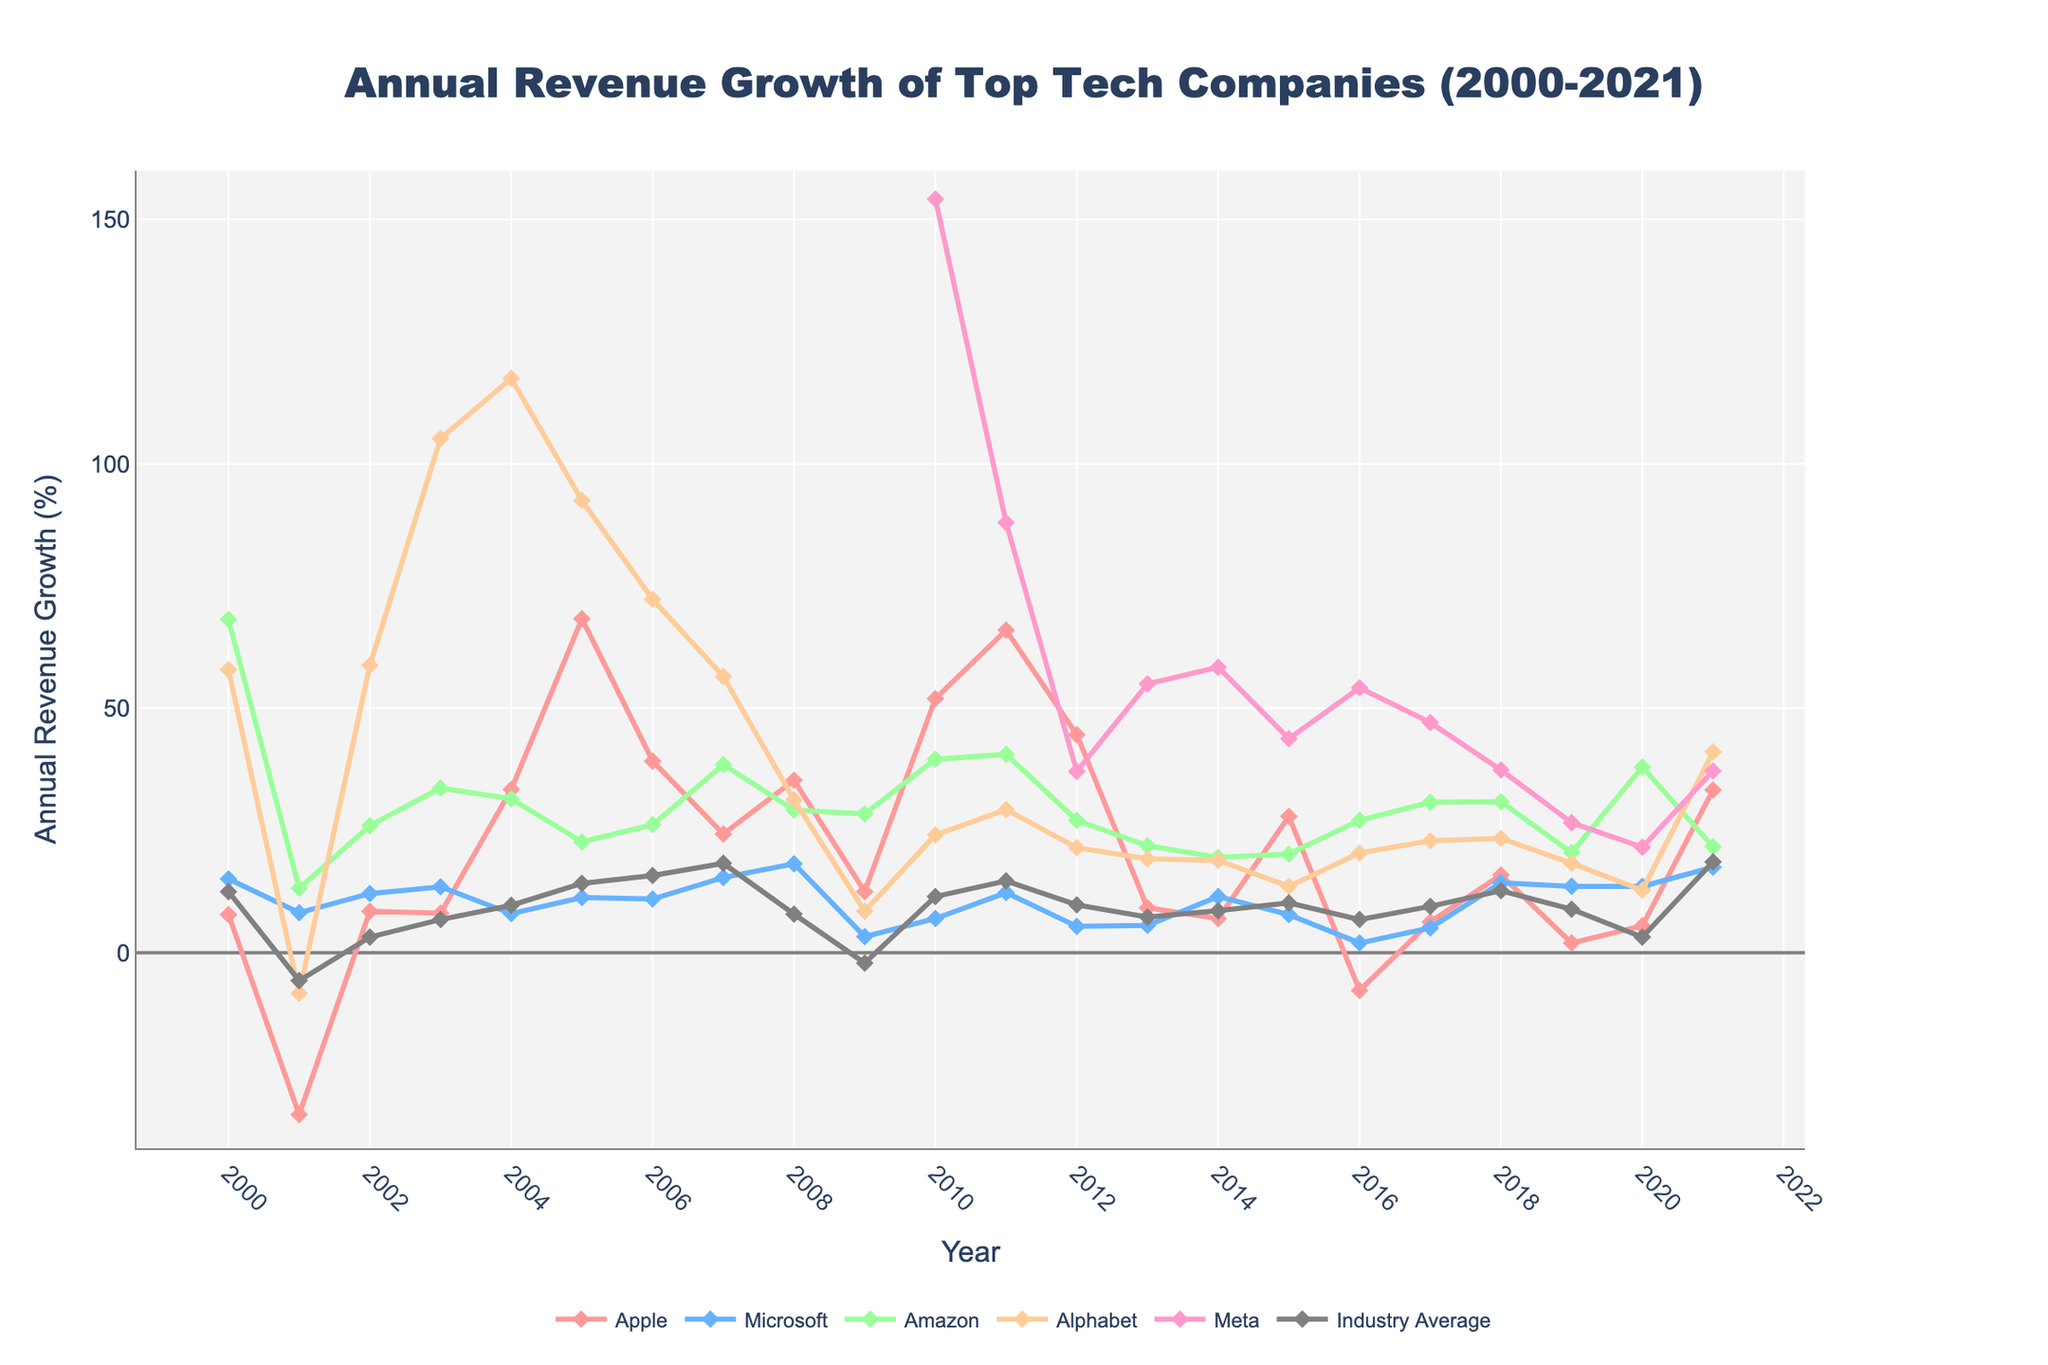What company had the highest revenue growth in 2010 and what was it? By examining the peaks for the year 2010, we note that Meta had the highest spike. The growth percentage for Meta in 2010 was 154.2%.
Answer: Meta, 154.2% Which company experienced the sharpest decline in revenue growth from 2000 to 2001? Comparing the revenue growth at 2000 and 2001 for each company, Apple shows the most significant decline from 7.8% in 2000 to -33.1% in 2001. The difference is calculated as 7.8 - (-33.1) = 40.9%.
Answer: Apple In which year did Alphabet and Microsoft both experience revenue growth greater than 10%? Visually inspecting the lines for Alphabet and Microsoft, in 2005 both companies show growth - Alphabet (92.5%) and Microsoft (11.3%).
Answer: 2005 How does Amazon’s revenue growth in 2020 compare to its growth in 2005? In 2005, Amazon's growth was 22.7% while in 2020 it was 38.0%. Therefore, Amazon's revenue growth in 2020 was 15.3 percentage points higher than in 2005.
Answer: 2020 was 15.3 percentage points higher Which years had the industry average below 0%? Reviewing the trend for Industry Average, the years 2001 (-5.7%) and 2009 (-2.1%) show negative growth values.
Answer: 2001, 2009 Was there any year when the revenue growth of all listed companies exceeded the industry average? By comparing each year’s growth, 2021 shows that all companies had a growth exceeding the industry average of 18.6%. Each company’s value is greater than 18.6%.
Answer: 2021 Which company demonstrated the most consistent annual growth trend from 2010 to 2021? Evaluating the stability and gradual trends from 2010 to 2021, Microsoft shows the most steady growth pattern without major peaks or declines compared to other companies.
Answer: Microsoft How did Meta’s revenue growth in 2010 compare to its growth in 2011 and 2012? Meta's growth was 154.2% in 2010, 88.0% in 2011, and 37.1% in 2012, indicating a substantial decrease each year.
Answer: Decreased significantly 